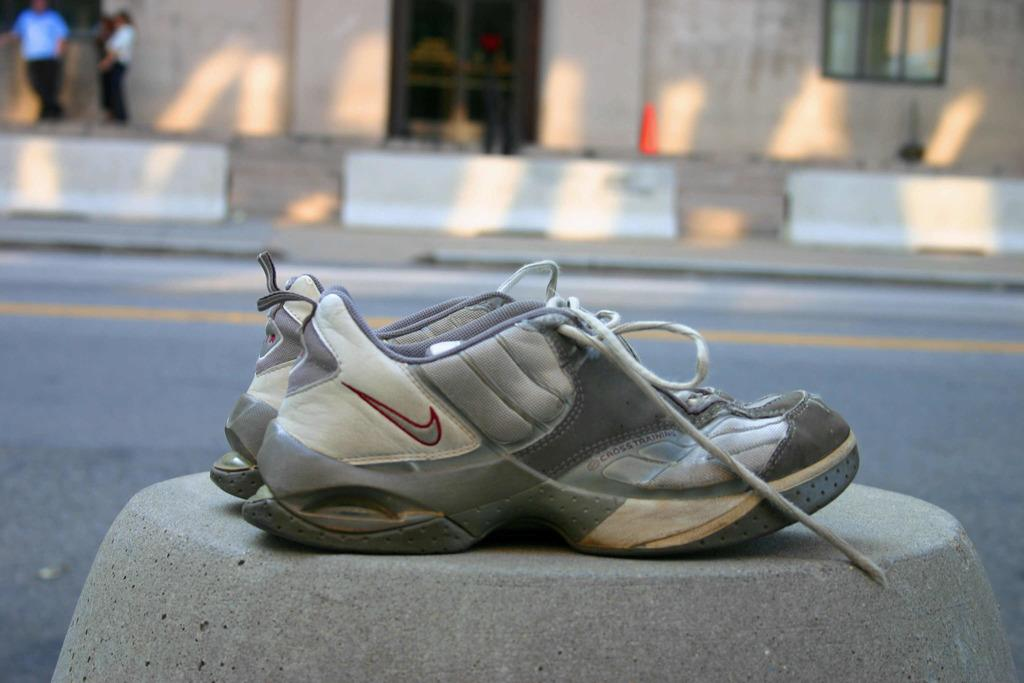What objects are present in the image? There are shoes in the image. What can be seen in the background of the image? There is a road and a footpath in the background of the image. How many people are on the footpath? There are three persons on the footpath. What type of water can be seen flowing under the footpath in the image? There is no water visible in the image, and the footpath is not shown to be above any water source. 